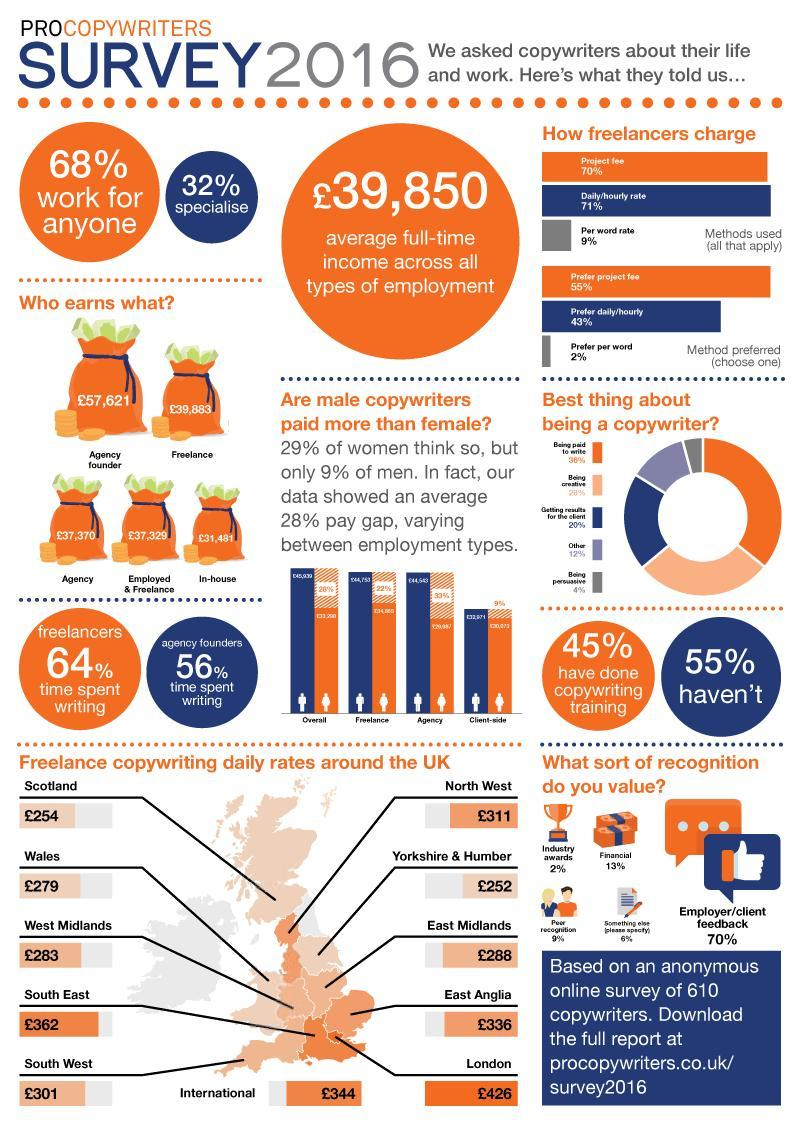What is the pay gap between men and women doing freelance?
Answer the question with a short phrase. 22% Which method used by freelancers has lowest charge? Per word rate What is the best thing about being a copywriter according to majority of people? Being paid to write In which employment type is the pay gap maximum? Agency Which is the second most preferred charging method of freelancers? Prefer daily/hourly Which form of recognition is most valued by copywriters? Employer/client feedback What percent did not have copywriting training? 55% Around UK, where is the copywriting daily rates the minimum? Yorkshire & Humber 